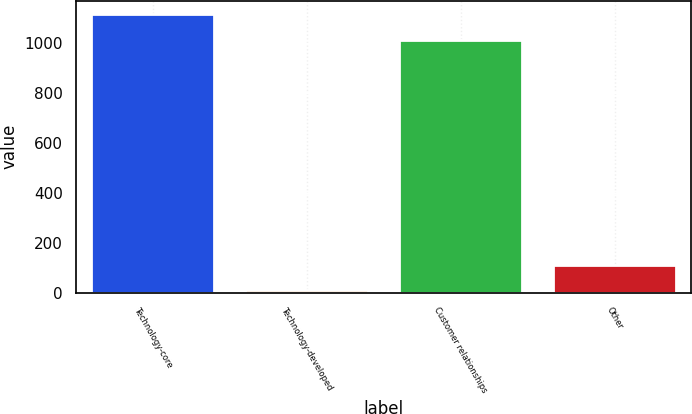<chart> <loc_0><loc_0><loc_500><loc_500><bar_chart><fcel>Technology-core<fcel>Technology-developed<fcel>Customer relationships<fcel>Other<nl><fcel>1113.6<fcel>10<fcel>1013<fcel>110.6<nl></chart> 